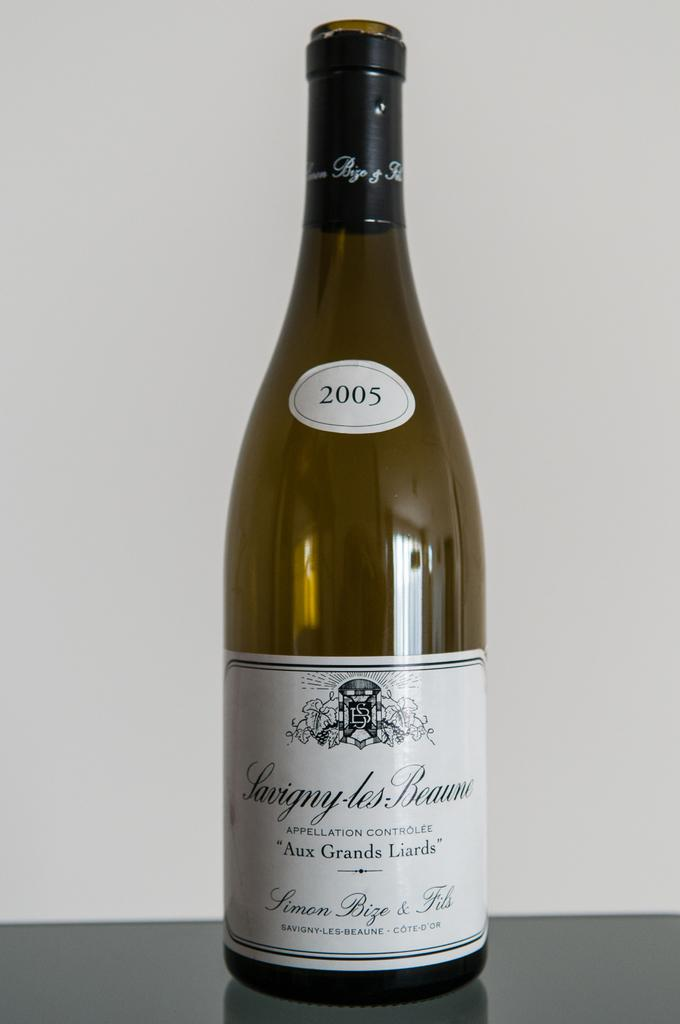<image>
Provide a brief description of the given image. Bottle of wine from 2005 on top of a table. 